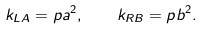Convert formula to latex. <formula><loc_0><loc_0><loc_500><loc_500>k _ { L A } = p a ^ { 2 } , \quad k _ { R B } = p b ^ { 2 } .</formula> 